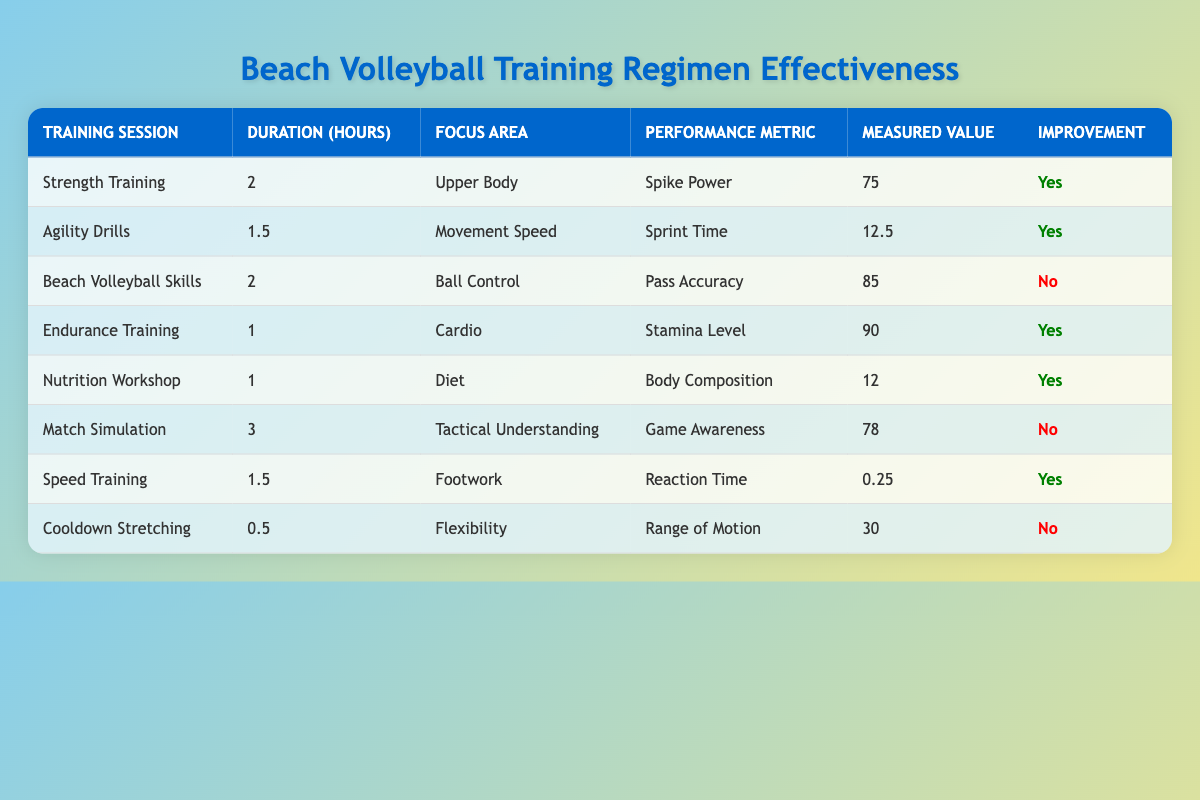What is the measured value for Spike Power in Strength Training? The measured value for Spike Power is specifically listed under the Strength Training session, which shows a Measured Value of 75.
Answer: 75 How many hours were spent on Speed Training? The Speed Training session indicates a duration of 1.5 hours, which is directly stated in the table.
Answer: 1.5 Which training session focused on Ball Control? The training session that focused on Ball Control is "Beach Volleyball Skills," as indicated in the Focus Area column of that row.
Answer: Beach Volleyball Skills What is the total duration of all the training sessions that showed improvement? The sessions showing improvement are Strength Training (2 hours), Agility Drills (1.5 hours), Endurance Training (1 hour), Nutrition Workshop (1 hour), and Speed Training (1.5 hours). Summing these values gives 2 + 1.5 + 1 + 1 + 1.5 = 7 hours total.
Answer: 7 hours Is there an improvement shown in the Match Simulation training session? The Match Simulation row indicates "No" under the Improvement column, signifying that no improvement was registered for that particular training.
Answer: No What is the average measured value of the performance metrics for all training sessions? We sum the measured values from all sessions: 75 + 12.5 + 85 + 90 + 12 + 78 + 0.25 + 30 = 372. There are 8 sessions, so the average is 372 / 8 = 46.5.
Answer: 46.5 Which two training sessions had the longest durations and what were their improvements? The two sessions with the longest durations are Match Simulation (3 hours, No improvement) and Strength Training (2 hours, Yes improvement).
Answer: Match Simulation: No, Strength Training: Yes How many training sessions focused on flexibility? There is one training session, "Cooldown Stretching," that specifically focuses on flexibility as noted in the Focus Area column.
Answer: 1 Which performance metric under Beach Volleyball Skills did not show improvement? The performance metric for Beach Volleyball Skills is "Pass Accuracy," and it is noted in the Improvement column as "No."
Answer: Pass Accuracy 